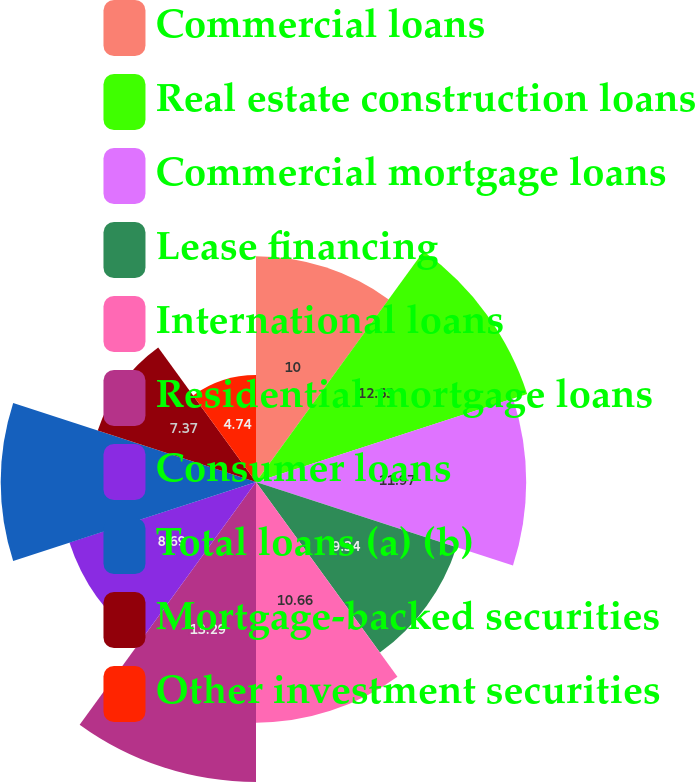Convert chart. <chart><loc_0><loc_0><loc_500><loc_500><pie_chart><fcel>Commercial loans<fcel>Real estate construction loans<fcel>Commercial mortgage loans<fcel>Lease financing<fcel>International loans<fcel>Residential mortgage loans<fcel>Consumer loans<fcel>Total loans (a) (b)<fcel>Mortgage-backed securities<fcel>Other investment securities<nl><fcel>10.0%<fcel>12.63%<fcel>11.97%<fcel>9.34%<fcel>10.66%<fcel>13.29%<fcel>8.69%<fcel>11.31%<fcel>7.37%<fcel>4.74%<nl></chart> 